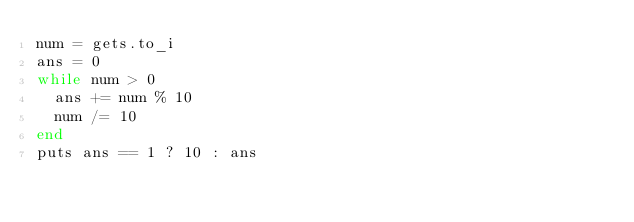<code> <loc_0><loc_0><loc_500><loc_500><_Ruby_>num = gets.to_i
ans = 0
while num > 0
  ans += num % 10
  num /= 10
end
puts ans == 1 ? 10 : ans</code> 